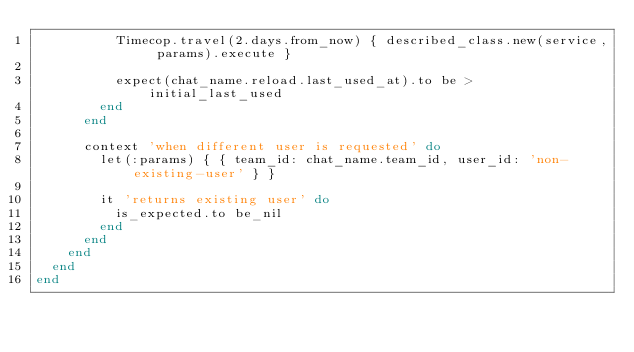<code> <loc_0><loc_0><loc_500><loc_500><_Ruby_>          Timecop.travel(2.days.from_now) { described_class.new(service, params).execute }

          expect(chat_name.reload.last_used_at).to be > initial_last_used
        end
      end

      context 'when different user is requested' do
        let(:params) { { team_id: chat_name.team_id, user_id: 'non-existing-user' } }

        it 'returns existing user' do
          is_expected.to be_nil
        end
      end
    end
  end
end
</code> 